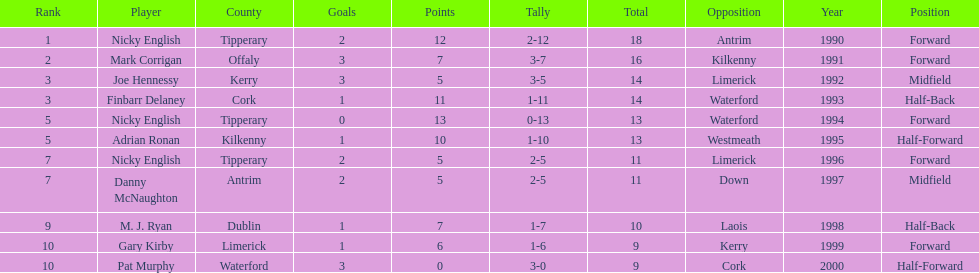What was the combined total of nicky english and mark corrigan? 34. 